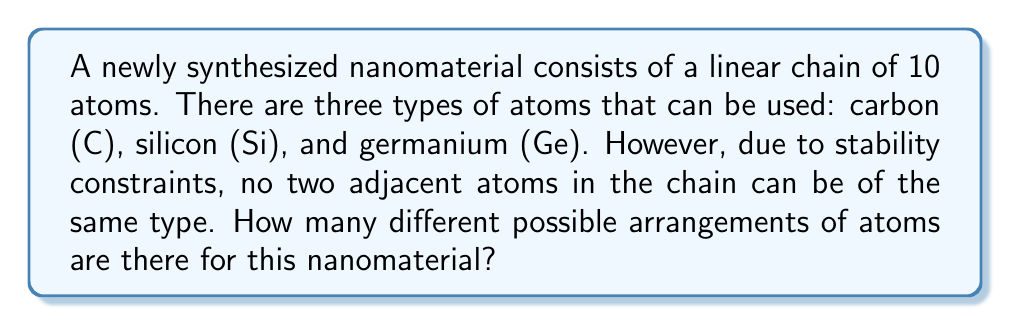Could you help me with this problem? Let's approach this problem step-by-step:

1) First, we need to recognize that this is a sequence problem with restrictions. We can use the multiplication principle, but we need to consider the constraint that no adjacent atoms can be the same.

2) Let's start by considering the first atom. We have 3 choices for this position (C, Si, or Ge).

3) For the second atom, we only have 2 choices, as it can't be the same as the first atom.

4) For each subsequent atom, we always have 2 choices, as it can't be the same as the previous atom.

5) Therefore, we can express the total number of arrangements as:

   $$ 3 \cdot 2^9 $$

   This is because we have 3 choices for the first position, and 2 choices for each of the remaining 9 positions.

6) Let's calculate this:
   $$ 3 \cdot 2^9 = 3 \cdot 512 = 1536 $$

7) We can verify this result by considering that this problem is equivalent to counting the number of valid colorings of a path graph with 10 vertices using 3 colors, where no adjacent vertices can have the same color. This is a well-known variation of the chromatic polynomial problem.
Answer: There are 1536 different possible arrangements of atoms for this nanomaterial. 